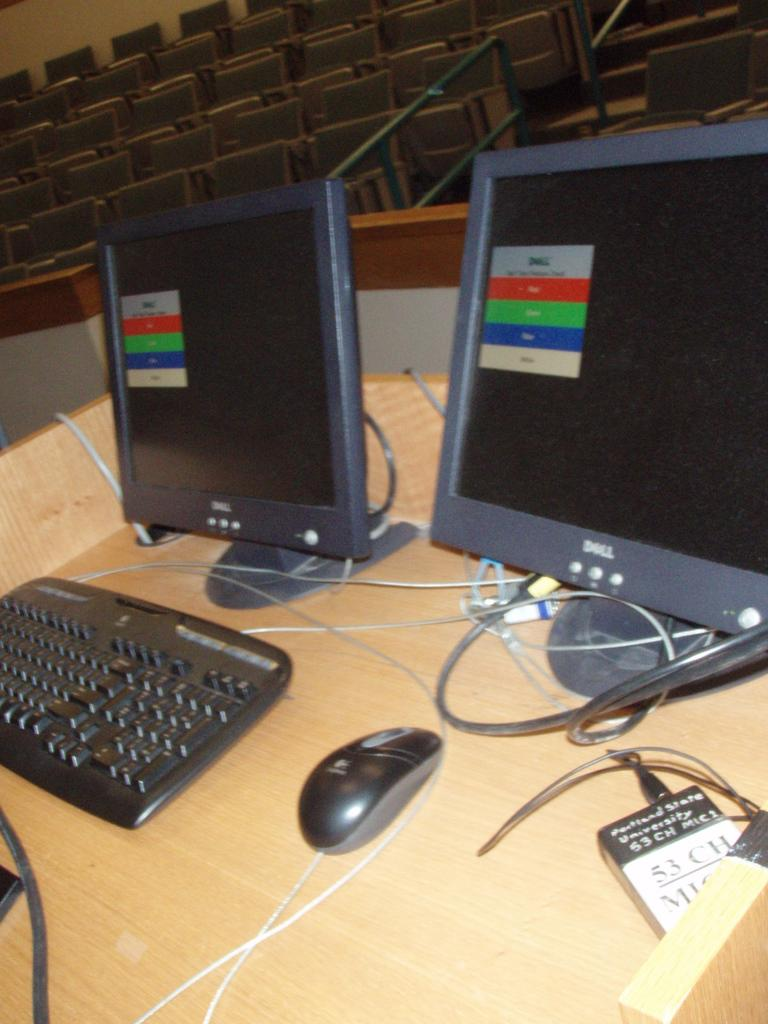<image>
Provide a brief description of the given image. A pair of computer monitors that say Dell are on a wooden desk in a class room. 